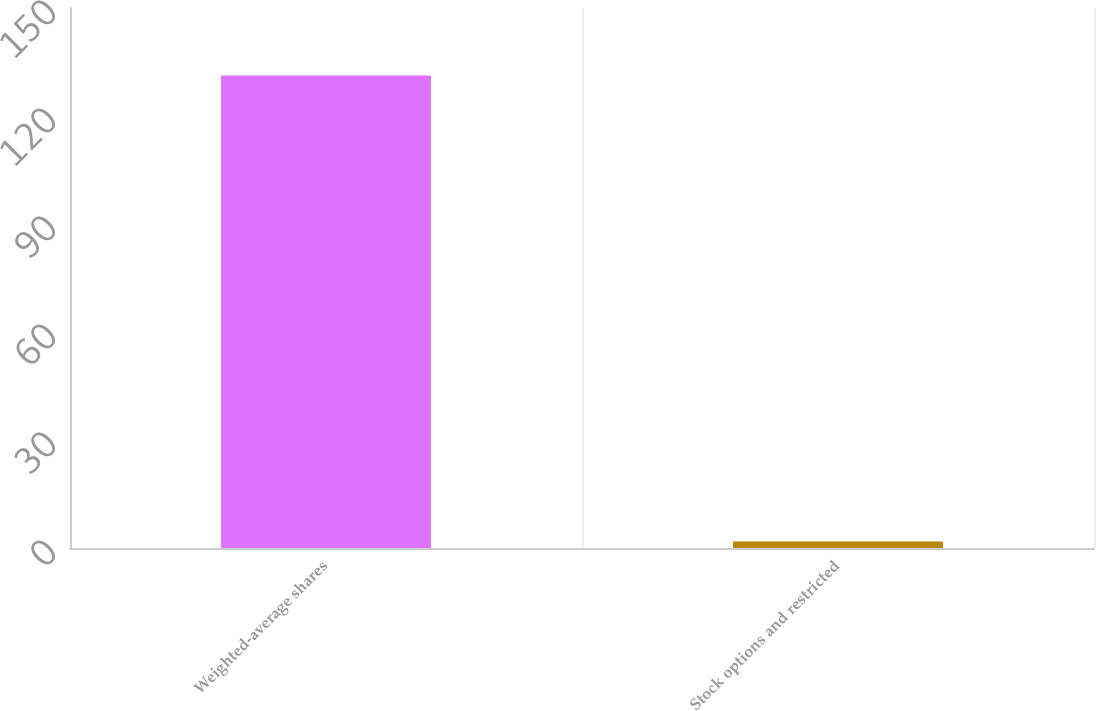Convert chart to OTSL. <chart><loc_0><loc_0><loc_500><loc_500><bar_chart><fcel>Weighted-average shares<fcel>Stock options and restricted<nl><fcel>131.23<fcel>1.8<nl></chart> 